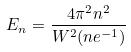<formula> <loc_0><loc_0><loc_500><loc_500>E _ { n } = \frac { 4 \pi ^ { 2 } n ^ { 2 } } { W ^ { 2 } ( n e ^ { - 1 } ) }</formula> 